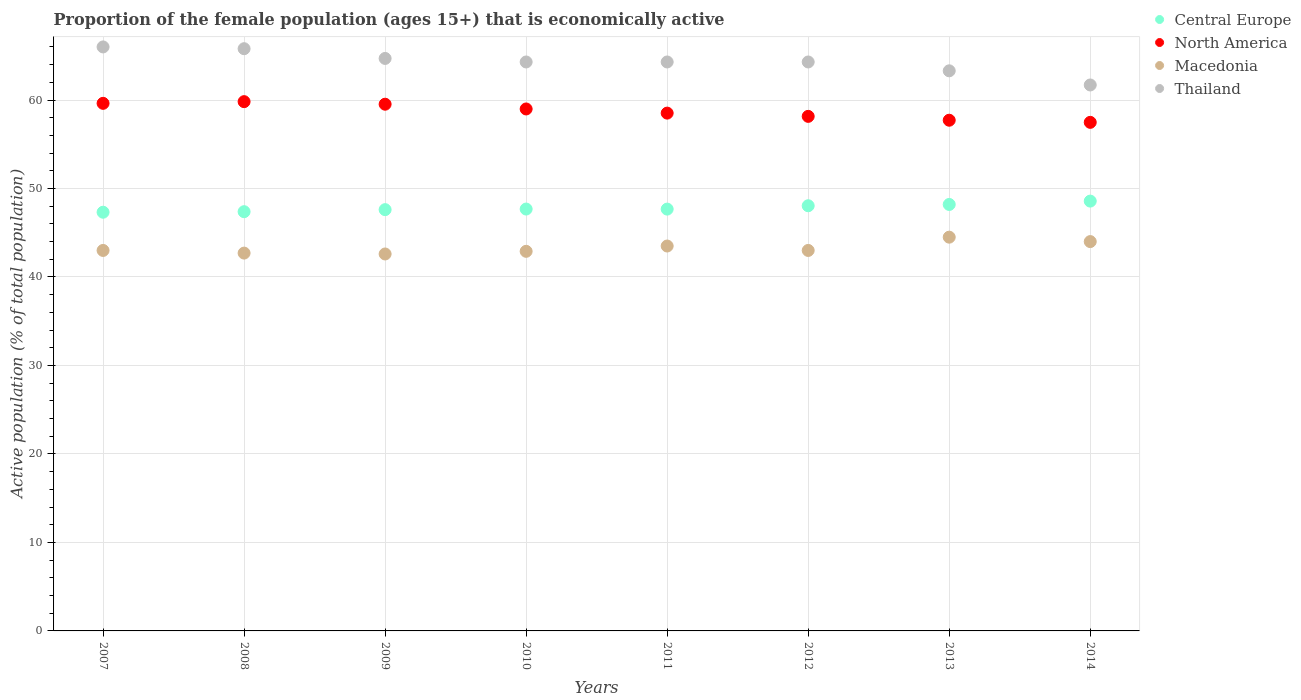What is the proportion of the female population that is economically active in Thailand in 2013?
Make the answer very short. 63.3. Across all years, what is the maximum proportion of the female population that is economically active in North America?
Your answer should be compact. 59.82. Across all years, what is the minimum proportion of the female population that is economically active in Macedonia?
Offer a very short reply. 42.6. In which year was the proportion of the female population that is economically active in Macedonia maximum?
Your answer should be compact. 2013. What is the total proportion of the female population that is economically active in Thailand in the graph?
Ensure brevity in your answer.  514.4. What is the difference between the proportion of the female population that is economically active in Central Europe in 2008 and that in 2014?
Provide a short and direct response. -1.2. What is the difference between the proportion of the female population that is economically active in Macedonia in 2013 and the proportion of the female population that is economically active in Central Europe in 2008?
Offer a very short reply. -2.88. What is the average proportion of the female population that is economically active in Macedonia per year?
Give a very brief answer. 43.28. In the year 2009, what is the difference between the proportion of the female population that is economically active in Central Europe and proportion of the female population that is economically active in Thailand?
Provide a short and direct response. -17.09. What is the ratio of the proportion of the female population that is economically active in Macedonia in 2008 to that in 2014?
Make the answer very short. 0.97. Is the difference between the proportion of the female population that is economically active in Central Europe in 2008 and 2011 greater than the difference between the proportion of the female population that is economically active in Thailand in 2008 and 2011?
Your answer should be very brief. No. What is the difference between the highest and the second highest proportion of the female population that is economically active in Thailand?
Your response must be concise. 0.2. What is the difference between the highest and the lowest proportion of the female population that is economically active in Central Europe?
Your response must be concise. 1.26. Is it the case that in every year, the sum of the proportion of the female population that is economically active in North America and proportion of the female population that is economically active in Central Europe  is greater than the proportion of the female population that is economically active in Thailand?
Ensure brevity in your answer.  Yes. Does the proportion of the female population that is economically active in Central Europe monotonically increase over the years?
Offer a very short reply. No. How many years are there in the graph?
Offer a terse response. 8. What is the difference between two consecutive major ticks on the Y-axis?
Keep it short and to the point. 10. Does the graph contain any zero values?
Make the answer very short. No. Does the graph contain grids?
Keep it short and to the point. Yes. Where does the legend appear in the graph?
Ensure brevity in your answer.  Top right. How many legend labels are there?
Your answer should be very brief. 4. What is the title of the graph?
Your answer should be very brief. Proportion of the female population (ages 15+) that is economically active. What is the label or title of the Y-axis?
Keep it short and to the point. Active population (% of total population). What is the Active population (% of total population) of Central Europe in 2007?
Keep it short and to the point. 47.32. What is the Active population (% of total population) of North America in 2007?
Your answer should be compact. 59.62. What is the Active population (% of total population) in Thailand in 2007?
Give a very brief answer. 66. What is the Active population (% of total population) in Central Europe in 2008?
Offer a terse response. 47.38. What is the Active population (% of total population) in North America in 2008?
Make the answer very short. 59.82. What is the Active population (% of total population) of Macedonia in 2008?
Your response must be concise. 42.7. What is the Active population (% of total population) of Thailand in 2008?
Offer a very short reply. 65.8. What is the Active population (% of total population) of Central Europe in 2009?
Offer a terse response. 47.61. What is the Active population (% of total population) in North America in 2009?
Offer a very short reply. 59.53. What is the Active population (% of total population) of Macedonia in 2009?
Provide a short and direct response. 42.6. What is the Active population (% of total population) of Thailand in 2009?
Provide a short and direct response. 64.7. What is the Active population (% of total population) in Central Europe in 2010?
Provide a succinct answer. 47.68. What is the Active population (% of total population) in North America in 2010?
Offer a very short reply. 58.99. What is the Active population (% of total population) in Macedonia in 2010?
Provide a short and direct response. 42.9. What is the Active population (% of total population) in Thailand in 2010?
Offer a very short reply. 64.3. What is the Active population (% of total population) in Central Europe in 2011?
Give a very brief answer. 47.67. What is the Active population (% of total population) in North America in 2011?
Provide a succinct answer. 58.52. What is the Active population (% of total population) of Macedonia in 2011?
Make the answer very short. 43.5. What is the Active population (% of total population) in Thailand in 2011?
Your answer should be compact. 64.3. What is the Active population (% of total population) of Central Europe in 2012?
Give a very brief answer. 48.05. What is the Active population (% of total population) in North America in 2012?
Give a very brief answer. 58.15. What is the Active population (% of total population) in Thailand in 2012?
Ensure brevity in your answer.  64.3. What is the Active population (% of total population) in Central Europe in 2013?
Make the answer very short. 48.2. What is the Active population (% of total population) in North America in 2013?
Your response must be concise. 57.72. What is the Active population (% of total population) in Macedonia in 2013?
Offer a terse response. 44.5. What is the Active population (% of total population) of Thailand in 2013?
Offer a terse response. 63.3. What is the Active population (% of total population) in Central Europe in 2014?
Provide a short and direct response. 48.58. What is the Active population (% of total population) of North America in 2014?
Your answer should be compact. 57.48. What is the Active population (% of total population) in Thailand in 2014?
Your answer should be very brief. 61.7. Across all years, what is the maximum Active population (% of total population) in Central Europe?
Offer a terse response. 48.58. Across all years, what is the maximum Active population (% of total population) of North America?
Keep it short and to the point. 59.82. Across all years, what is the maximum Active population (% of total population) of Macedonia?
Your answer should be very brief. 44.5. Across all years, what is the minimum Active population (% of total population) in Central Europe?
Your answer should be very brief. 47.32. Across all years, what is the minimum Active population (% of total population) in North America?
Ensure brevity in your answer.  57.48. Across all years, what is the minimum Active population (% of total population) in Macedonia?
Provide a succinct answer. 42.6. Across all years, what is the minimum Active population (% of total population) in Thailand?
Keep it short and to the point. 61.7. What is the total Active population (% of total population) of Central Europe in the graph?
Your response must be concise. 382.48. What is the total Active population (% of total population) of North America in the graph?
Offer a terse response. 469.82. What is the total Active population (% of total population) of Macedonia in the graph?
Ensure brevity in your answer.  346.2. What is the total Active population (% of total population) of Thailand in the graph?
Offer a terse response. 514.4. What is the difference between the Active population (% of total population) in Central Europe in 2007 and that in 2008?
Offer a very short reply. -0.06. What is the difference between the Active population (% of total population) of North America in 2007 and that in 2008?
Provide a succinct answer. -0.19. What is the difference between the Active population (% of total population) in Thailand in 2007 and that in 2008?
Your answer should be compact. 0.2. What is the difference between the Active population (% of total population) of Central Europe in 2007 and that in 2009?
Offer a terse response. -0.29. What is the difference between the Active population (% of total population) in North America in 2007 and that in 2009?
Your answer should be very brief. 0.1. What is the difference between the Active population (% of total population) in Central Europe in 2007 and that in 2010?
Make the answer very short. -0.36. What is the difference between the Active population (% of total population) in North America in 2007 and that in 2010?
Your answer should be compact. 0.64. What is the difference between the Active population (% of total population) in Thailand in 2007 and that in 2010?
Offer a very short reply. 1.7. What is the difference between the Active population (% of total population) of Central Europe in 2007 and that in 2011?
Give a very brief answer. -0.35. What is the difference between the Active population (% of total population) in North America in 2007 and that in 2011?
Provide a short and direct response. 1.1. What is the difference between the Active population (% of total population) of Thailand in 2007 and that in 2011?
Your answer should be very brief. 1.7. What is the difference between the Active population (% of total population) in Central Europe in 2007 and that in 2012?
Give a very brief answer. -0.73. What is the difference between the Active population (% of total population) of North America in 2007 and that in 2012?
Your answer should be very brief. 1.47. What is the difference between the Active population (% of total population) in Central Europe in 2007 and that in 2013?
Your response must be concise. -0.88. What is the difference between the Active population (% of total population) of North America in 2007 and that in 2013?
Ensure brevity in your answer.  1.91. What is the difference between the Active population (% of total population) of Central Europe in 2007 and that in 2014?
Make the answer very short. -1.26. What is the difference between the Active population (% of total population) of North America in 2007 and that in 2014?
Your answer should be compact. 2.15. What is the difference between the Active population (% of total population) in Macedonia in 2007 and that in 2014?
Provide a short and direct response. -1. What is the difference between the Active population (% of total population) of Central Europe in 2008 and that in 2009?
Give a very brief answer. -0.23. What is the difference between the Active population (% of total population) of North America in 2008 and that in 2009?
Ensure brevity in your answer.  0.29. What is the difference between the Active population (% of total population) of Central Europe in 2008 and that in 2010?
Give a very brief answer. -0.3. What is the difference between the Active population (% of total population) in North America in 2008 and that in 2010?
Your answer should be very brief. 0.83. What is the difference between the Active population (% of total population) of Macedonia in 2008 and that in 2010?
Give a very brief answer. -0.2. What is the difference between the Active population (% of total population) of Central Europe in 2008 and that in 2011?
Ensure brevity in your answer.  -0.29. What is the difference between the Active population (% of total population) in North America in 2008 and that in 2011?
Your answer should be very brief. 1.3. What is the difference between the Active population (% of total population) of Central Europe in 2008 and that in 2012?
Your response must be concise. -0.67. What is the difference between the Active population (% of total population) in North America in 2008 and that in 2012?
Give a very brief answer. 1.66. What is the difference between the Active population (% of total population) in Thailand in 2008 and that in 2012?
Keep it short and to the point. 1.5. What is the difference between the Active population (% of total population) in Central Europe in 2008 and that in 2013?
Make the answer very short. -0.82. What is the difference between the Active population (% of total population) in North America in 2008 and that in 2013?
Provide a short and direct response. 2.1. What is the difference between the Active population (% of total population) of Macedonia in 2008 and that in 2013?
Provide a succinct answer. -1.8. What is the difference between the Active population (% of total population) in Thailand in 2008 and that in 2013?
Make the answer very short. 2.5. What is the difference between the Active population (% of total population) of Central Europe in 2008 and that in 2014?
Give a very brief answer. -1.2. What is the difference between the Active population (% of total population) of North America in 2008 and that in 2014?
Make the answer very short. 2.34. What is the difference between the Active population (% of total population) of Macedonia in 2008 and that in 2014?
Give a very brief answer. -1.3. What is the difference between the Active population (% of total population) in Thailand in 2008 and that in 2014?
Offer a very short reply. 4.1. What is the difference between the Active population (% of total population) in Central Europe in 2009 and that in 2010?
Ensure brevity in your answer.  -0.07. What is the difference between the Active population (% of total population) of North America in 2009 and that in 2010?
Make the answer very short. 0.54. What is the difference between the Active population (% of total population) of Macedonia in 2009 and that in 2010?
Provide a short and direct response. -0.3. What is the difference between the Active population (% of total population) in Central Europe in 2009 and that in 2011?
Your answer should be very brief. -0.06. What is the difference between the Active population (% of total population) of North America in 2009 and that in 2011?
Provide a succinct answer. 1.01. What is the difference between the Active population (% of total population) in Macedonia in 2009 and that in 2011?
Give a very brief answer. -0.9. What is the difference between the Active population (% of total population) of Thailand in 2009 and that in 2011?
Your answer should be very brief. 0.4. What is the difference between the Active population (% of total population) of Central Europe in 2009 and that in 2012?
Offer a terse response. -0.44. What is the difference between the Active population (% of total population) of North America in 2009 and that in 2012?
Give a very brief answer. 1.37. What is the difference between the Active population (% of total population) in Thailand in 2009 and that in 2012?
Keep it short and to the point. 0.4. What is the difference between the Active population (% of total population) in Central Europe in 2009 and that in 2013?
Offer a very short reply. -0.59. What is the difference between the Active population (% of total population) of North America in 2009 and that in 2013?
Ensure brevity in your answer.  1.81. What is the difference between the Active population (% of total population) in Thailand in 2009 and that in 2013?
Provide a short and direct response. 1.4. What is the difference between the Active population (% of total population) in Central Europe in 2009 and that in 2014?
Make the answer very short. -0.97. What is the difference between the Active population (% of total population) of North America in 2009 and that in 2014?
Offer a terse response. 2.05. What is the difference between the Active population (% of total population) in Thailand in 2009 and that in 2014?
Your answer should be very brief. 3. What is the difference between the Active population (% of total population) in Central Europe in 2010 and that in 2011?
Offer a very short reply. 0.01. What is the difference between the Active population (% of total population) in North America in 2010 and that in 2011?
Your answer should be compact. 0.47. What is the difference between the Active population (% of total population) of Macedonia in 2010 and that in 2011?
Provide a short and direct response. -0.6. What is the difference between the Active population (% of total population) in Thailand in 2010 and that in 2011?
Give a very brief answer. 0. What is the difference between the Active population (% of total population) of Central Europe in 2010 and that in 2012?
Your answer should be compact. -0.37. What is the difference between the Active population (% of total population) of North America in 2010 and that in 2012?
Your answer should be very brief. 0.84. What is the difference between the Active population (% of total population) in Macedonia in 2010 and that in 2012?
Keep it short and to the point. -0.1. What is the difference between the Active population (% of total population) of Central Europe in 2010 and that in 2013?
Make the answer very short. -0.52. What is the difference between the Active population (% of total population) of North America in 2010 and that in 2013?
Your answer should be very brief. 1.27. What is the difference between the Active population (% of total population) in Macedonia in 2010 and that in 2013?
Provide a succinct answer. -1.6. What is the difference between the Active population (% of total population) in Thailand in 2010 and that in 2013?
Make the answer very short. 1. What is the difference between the Active population (% of total population) of Central Europe in 2010 and that in 2014?
Offer a very short reply. -0.9. What is the difference between the Active population (% of total population) in North America in 2010 and that in 2014?
Your answer should be very brief. 1.51. What is the difference between the Active population (% of total population) of Central Europe in 2011 and that in 2012?
Keep it short and to the point. -0.38. What is the difference between the Active population (% of total population) of North America in 2011 and that in 2012?
Your answer should be compact. 0.37. What is the difference between the Active population (% of total population) of Thailand in 2011 and that in 2012?
Your response must be concise. 0. What is the difference between the Active population (% of total population) of Central Europe in 2011 and that in 2013?
Offer a very short reply. -0.52. What is the difference between the Active population (% of total population) in North America in 2011 and that in 2013?
Your answer should be very brief. 0.8. What is the difference between the Active population (% of total population) in Macedonia in 2011 and that in 2013?
Offer a terse response. -1. What is the difference between the Active population (% of total population) in Central Europe in 2011 and that in 2014?
Your response must be concise. -0.9. What is the difference between the Active population (% of total population) in North America in 2011 and that in 2014?
Ensure brevity in your answer.  1.04. What is the difference between the Active population (% of total population) in Thailand in 2011 and that in 2014?
Your answer should be very brief. 2.6. What is the difference between the Active population (% of total population) in Central Europe in 2012 and that in 2013?
Your answer should be compact. -0.14. What is the difference between the Active population (% of total population) in North America in 2012 and that in 2013?
Your answer should be very brief. 0.44. What is the difference between the Active population (% of total population) of Central Europe in 2012 and that in 2014?
Keep it short and to the point. -0.53. What is the difference between the Active population (% of total population) in North America in 2012 and that in 2014?
Keep it short and to the point. 0.68. What is the difference between the Active population (% of total population) in Central Europe in 2013 and that in 2014?
Your answer should be very brief. -0.38. What is the difference between the Active population (% of total population) of North America in 2013 and that in 2014?
Give a very brief answer. 0.24. What is the difference between the Active population (% of total population) of Central Europe in 2007 and the Active population (% of total population) of North America in 2008?
Offer a very short reply. -12.5. What is the difference between the Active population (% of total population) of Central Europe in 2007 and the Active population (% of total population) of Macedonia in 2008?
Ensure brevity in your answer.  4.62. What is the difference between the Active population (% of total population) in Central Europe in 2007 and the Active population (% of total population) in Thailand in 2008?
Provide a short and direct response. -18.48. What is the difference between the Active population (% of total population) in North America in 2007 and the Active population (% of total population) in Macedonia in 2008?
Your answer should be very brief. 16.92. What is the difference between the Active population (% of total population) in North America in 2007 and the Active population (% of total population) in Thailand in 2008?
Your response must be concise. -6.18. What is the difference between the Active population (% of total population) of Macedonia in 2007 and the Active population (% of total population) of Thailand in 2008?
Give a very brief answer. -22.8. What is the difference between the Active population (% of total population) of Central Europe in 2007 and the Active population (% of total population) of North America in 2009?
Offer a terse response. -12.21. What is the difference between the Active population (% of total population) in Central Europe in 2007 and the Active population (% of total population) in Macedonia in 2009?
Your answer should be compact. 4.72. What is the difference between the Active population (% of total population) in Central Europe in 2007 and the Active population (% of total population) in Thailand in 2009?
Provide a short and direct response. -17.38. What is the difference between the Active population (% of total population) in North America in 2007 and the Active population (% of total population) in Macedonia in 2009?
Your answer should be compact. 17.02. What is the difference between the Active population (% of total population) in North America in 2007 and the Active population (% of total population) in Thailand in 2009?
Keep it short and to the point. -5.08. What is the difference between the Active population (% of total population) in Macedonia in 2007 and the Active population (% of total population) in Thailand in 2009?
Your response must be concise. -21.7. What is the difference between the Active population (% of total population) in Central Europe in 2007 and the Active population (% of total population) in North America in 2010?
Offer a terse response. -11.67. What is the difference between the Active population (% of total population) in Central Europe in 2007 and the Active population (% of total population) in Macedonia in 2010?
Provide a short and direct response. 4.42. What is the difference between the Active population (% of total population) of Central Europe in 2007 and the Active population (% of total population) of Thailand in 2010?
Provide a succinct answer. -16.98. What is the difference between the Active population (% of total population) of North America in 2007 and the Active population (% of total population) of Macedonia in 2010?
Keep it short and to the point. 16.72. What is the difference between the Active population (% of total population) of North America in 2007 and the Active population (% of total population) of Thailand in 2010?
Provide a short and direct response. -4.68. What is the difference between the Active population (% of total population) in Macedonia in 2007 and the Active population (% of total population) in Thailand in 2010?
Ensure brevity in your answer.  -21.3. What is the difference between the Active population (% of total population) of Central Europe in 2007 and the Active population (% of total population) of North America in 2011?
Keep it short and to the point. -11.2. What is the difference between the Active population (% of total population) in Central Europe in 2007 and the Active population (% of total population) in Macedonia in 2011?
Make the answer very short. 3.82. What is the difference between the Active population (% of total population) of Central Europe in 2007 and the Active population (% of total population) of Thailand in 2011?
Offer a terse response. -16.98. What is the difference between the Active population (% of total population) of North America in 2007 and the Active population (% of total population) of Macedonia in 2011?
Ensure brevity in your answer.  16.12. What is the difference between the Active population (% of total population) of North America in 2007 and the Active population (% of total population) of Thailand in 2011?
Your answer should be compact. -4.68. What is the difference between the Active population (% of total population) of Macedonia in 2007 and the Active population (% of total population) of Thailand in 2011?
Your answer should be compact. -21.3. What is the difference between the Active population (% of total population) in Central Europe in 2007 and the Active population (% of total population) in North America in 2012?
Give a very brief answer. -10.83. What is the difference between the Active population (% of total population) in Central Europe in 2007 and the Active population (% of total population) in Macedonia in 2012?
Offer a very short reply. 4.32. What is the difference between the Active population (% of total population) of Central Europe in 2007 and the Active population (% of total population) of Thailand in 2012?
Provide a short and direct response. -16.98. What is the difference between the Active population (% of total population) of North America in 2007 and the Active population (% of total population) of Macedonia in 2012?
Provide a succinct answer. 16.62. What is the difference between the Active population (% of total population) of North America in 2007 and the Active population (% of total population) of Thailand in 2012?
Offer a very short reply. -4.68. What is the difference between the Active population (% of total population) of Macedonia in 2007 and the Active population (% of total population) of Thailand in 2012?
Your response must be concise. -21.3. What is the difference between the Active population (% of total population) of Central Europe in 2007 and the Active population (% of total population) of North America in 2013?
Make the answer very short. -10.4. What is the difference between the Active population (% of total population) in Central Europe in 2007 and the Active population (% of total population) in Macedonia in 2013?
Your response must be concise. 2.82. What is the difference between the Active population (% of total population) in Central Europe in 2007 and the Active population (% of total population) in Thailand in 2013?
Your answer should be very brief. -15.98. What is the difference between the Active population (% of total population) in North America in 2007 and the Active population (% of total population) in Macedonia in 2013?
Your answer should be compact. 15.12. What is the difference between the Active population (% of total population) in North America in 2007 and the Active population (% of total population) in Thailand in 2013?
Ensure brevity in your answer.  -3.68. What is the difference between the Active population (% of total population) of Macedonia in 2007 and the Active population (% of total population) of Thailand in 2013?
Offer a very short reply. -20.3. What is the difference between the Active population (% of total population) of Central Europe in 2007 and the Active population (% of total population) of North America in 2014?
Provide a succinct answer. -10.16. What is the difference between the Active population (% of total population) in Central Europe in 2007 and the Active population (% of total population) in Macedonia in 2014?
Give a very brief answer. 3.32. What is the difference between the Active population (% of total population) in Central Europe in 2007 and the Active population (% of total population) in Thailand in 2014?
Offer a very short reply. -14.38. What is the difference between the Active population (% of total population) in North America in 2007 and the Active population (% of total population) in Macedonia in 2014?
Give a very brief answer. 15.62. What is the difference between the Active population (% of total population) in North America in 2007 and the Active population (% of total population) in Thailand in 2014?
Your answer should be compact. -2.08. What is the difference between the Active population (% of total population) in Macedonia in 2007 and the Active population (% of total population) in Thailand in 2014?
Offer a very short reply. -18.7. What is the difference between the Active population (% of total population) of Central Europe in 2008 and the Active population (% of total population) of North America in 2009?
Offer a terse response. -12.15. What is the difference between the Active population (% of total population) in Central Europe in 2008 and the Active population (% of total population) in Macedonia in 2009?
Give a very brief answer. 4.78. What is the difference between the Active population (% of total population) of Central Europe in 2008 and the Active population (% of total population) of Thailand in 2009?
Give a very brief answer. -17.32. What is the difference between the Active population (% of total population) of North America in 2008 and the Active population (% of total population) of Macedonia in 2009?
Provide a succinct answer. 17.22. What is the difference between the Active population (% of total population) of North America in 2008 and the Active population (% of total population) of Thailand in 2009?
Your answer should be very brief. -4.88. What is the difference between the Active population (% of total population) of Central Europe in 2008 and the Active population (% of total population) of North America in 2010?
Ensure brevity in your answer.  -11.61. What is the difference between the Active population (% of total population) in Central Europe in 2008 and the Active population (% of total population) in Macedonia in 2010?
Make the answer very short. 4.48. What is the difference between the Active population (% of total population) of Central Europe in 2008 and the Active population (% of total population) of Thailand in 2010?
Provide a succinct answer. -16.92. What is the difference between the Active population (% of total population) of North America in 2008 and the Active population (% of total population) of Macedonia in 2010?
Make the answer very short. 16.92. What is the difference between the Active population (% of total population) in North America in 2008 and the Active population (% of total population) in Thailand in 2010?
Offer a terse response. -4.48. What is the difference between the Active population (% of total population) of Macedonia in 2008 and the Active population (% of total population) of Thailand in 2010?
Offer a very short reply. -21.6. What is the difference between the Active population (% of total population) of Central Europe in 2008 and the Active population (% of total population) of North America in 2011?
Offer a terse response. -11.14. What is the difference between the Active population (% of total population) of Central Europe in 2008 and the Active population (% of total population) of Macedonia in 2011?
Keep it short and to the point. 3.88. What is the difference between the Active population (% of total population) of Central Europe in 2008 and the Active population (% of total population) of Thailand in 2011?
Give a very brief answer. -16.92. What is the difference between the Active population (% of total population) in North America in 2008 and the Active population (% of total population) in Macedonia in 2011?
Keep it short and to the point. 16.32. What is the difference between the Active population (% of total population) in North America in 2008 and the Active population (% of total population) in Thailand in 2011?
Your answer should be compact. -4.48. What is the difference between the Active population (% of total population) in Macedonia in 2008 and the Active population (% of total population) in Thailand in 2011?
Your answer should be compact. -21.6. What is the difference between the Active population (% of total population) in Central Europe in 2008 and the Active population (% of total population) in North America in 2012?
Your answer should be compact. -10.77. What is the difference between the Active population (% of total population) of Central Europe in 2008 and the Active population (% of total population) of Macedonia in 2012?
Make the answer very short. 4.38. What is the difference between the Active population (% of total population) in Central Europe in 2008 and the Active population (% of total population) in Thailand in 2012?
Your response must be concise. -16.92. What is the difference between the Active population (% of total population) of North America in 2008 and the Active population (% of total population) of Macedonia in 2012?
Keep it short and to the point. 16.82. What is the difference between the Active population (% of total population) in North America in 2008 and the Active population (% of total population) in Thailand in 2012?
Make the answer very short. -4.48. What is the difference between the Active population (% of total population) in Macedonia in 2008 and the Active population (% of total population) in Thailand in 2012?
Keep it short and to the point. -21.6. What is the difference between the Active population (% of total population) in Central Europe in 2008 and the Active population (% of total population) in North America in 2013?
Keep it short and to the point. -10.34. What is the difference between the Active population (% of total population) in Central Europe in 2008 and the Active population (% of total population) in Macedonia in 2013?
Keep it short and to the point. 2.88. What is the difference between the Active population (% of total population) of Central Europe in 2008 and the Active population (% of total population) of Thailand in 2013?
Offer a terse response. -15.92. What is the difference between the Active population (% of total population) of North America in 2008 and the Active population (% of total population) of Macedonia in 2013?
Your response must be concise. 15.32. What is the difference between the Active population (% of total population) in North America in 2008 and the Active population (% of total population) in Thailand in 2013?
Offer a very short reply. -3.48. What is the difference between the Active population (% of total population) of Macedonia in 2008 and the Active population (% of total population) of Thailand in 2013?
Ensure brevity in your answer.  -20.6. What is the difference between the Active population (% of total population) in Central Europe in 2008 and the Active population (% of total population) in North America in 2014?
Give a very brief answer. -10.1. What is the difference between the Active population (% of total population) in Central Europe in 2008 and the Active population (% of total population) in Macedonia in 2014?
Make the answer very short. 3.38. What is the difference between the Active population (% of total population) of Central Europe in 2008 and the Active population (% of total population) of Thailand in 2014?
Provide a succinct answer. -14.32. What is the difference between the Active population (% of total population) in North America in 2008 and the Active population (% of total population) in Macedonia in 2014?
Offer a terse response. 15.82. What is the difference between the Active population (% of total population) of North America in 2008 and the Active population (% of total population) of Thailand in 2014?
Offer a very short reply. -1.88. What is the difference between the Active population (% of total population) in Central Europe in 2009 and the Active population (% of total population) in North America in 2010?
Your answer should be very brief. -11.38. What is the difference between the Active population (% of total population) in Central Europe in 2009 and the Active population (% of total population) in Macedonia in 2010?
Give a very brief answer. 4.71. What is the difference between the Active population (% of total population) in Central Europe in 2009 and the Active population (% of total population) in Thailand in 2010?
Give a very brief answer. -16.69. What is the difference between the Active population (% of total population) in North America in 2009 and the Active population (% of total population) in Macedonia in 2010?
Your response must be concise. 16.63. What is the difference between the Active population (% of total population) of North America in 2009 and the Active population (% of total population) of Thailand in 2010?
Your answer should be compact. -4.77. What is the difference between the Active population (% of total population) of Macedonia in 2009 and the Active population (% of total population) of Thailand in 2010?
Your answer should be very brief. -21.7. What is the difference between the Active population (% of total population) of Central Europe in 2009 and the Active population (% of total population) of North America in 2011?
Provide a short and direct response. -10.91. What is the difference between the Active population (% of total population) in Central Europe in 2009 and the Active population (% of total population) in Macedonia in 2011?
Offer a terse response. 4.11. What is the difference between the Active population (% of total population) in Central Europe in 2009 and the Active population (% of total population) in Thailand in 2011?
Ensure brevity in your answer.  -16.69. What is the difference between the Active population (% of total population) of North America in 2009 and the Active population (% of total population) of Macedonia in 2011?
Ensure brevity in your answer.  16.03. What is the difference between the Active population (% of total population) in North America in 2009 and the Active population (% of total population) in Thailand in 2011?
Give a very brief answer. -4.77. What is the difference between the Active population (% of total population) in Macedonia in 2009 and the Active population (% of total population) in Thailand in 2011?
Your response must be concise. -21.7. What is the difference between the Active population (% of total population) in Central Europe in 2009 and the Active population (% of total population) in North America in 2012?
Your response must be concise. -10.54. What is the difference between the Active population (% of total population) in Central Europe in 2009 and the Active population (% of total population) in Macedonia in 2012?
Give a very brief answer. 4.61. What is the difference between the Active population (% of total population) in Central Europe in 2009 and the Active population (% of total population) in Thailand in 2012?
Keep it short and to the point. -16.69. What is the difference between the Active population (% of total population) in North America in 2009 and the Active population (% of total population) in Macedonia in 2012?
Make the answer very short. 16.53. What is the difference between the Active population (% of total population) in North America in 2009 and the Active population (% of total population) in Thailand in 2012?
Give a very brief answer. -4.77. What is the difference between the Active population (% of total population) of Macedonia in 2009 and the Active population (% of total population) of Thailand in 2012?
Your answer should be compact. -21.7. What is the difference between the Active population (% of total population) of Central Europe in 2009 and the Active population (% of total population) of North America in 2013?
Offer a terse response. -10.11. What is the difference between the Active population (% of total population) of Central Europe in 2009 and the Active population (% of total population) of Macedonia in 2013?
Your answer should be compact. 3.11. What is the difference between the Active population (% of total population) in Central Europe in 2009 and the Active population (% of total population) in Thailand in 2013?
Give a very brief answer. -15.69. What is the difference between the Active population (% of total population) of North America in 2009 and the Active population (% of total population) of Macedonia in 2013?
Provide a short and direct response. 15.03. What is the difference between the Active population (% of total population) of North America in 2009 and the Active population (% of total population) of Thailand in 2013?
Give a very brief answer. -3.77. What is the difference between the Active population (% of total population) in Macedonia in 2009 and the Active population (% of total population) in Thailand in 2013?
Offer a very short reply. -20.7. What is the difference between the Active population (% of total population) in Central Europe in 2009 and the Active population (% of total population) in North America in 2014?
Your answer should be compact. -9.87. What is the difference between the Active population (% of total population) in Central Europe in 2009 and the Active population (% of total population) in Macedonia in 2014?
Make the answer very short. 3.61. What is the difference between the Active population (% of total population) of Central Europe in 2009 and the Active population (% of total population) of Thailand in 2014?
Provide a short and direct response. -14.09. What is the difference between the Active population (% of total population) in North America in 2009 and the Active population (% of total population) in Macedonia in 2014?
Provide a short and direct response. 15.53. What is the difference between the Active population (% of total population) in North America in 2009 and the Active population (% of total population) in Thailand in 2014?
Your answer should be very brief. -2.17. What is the difference between the Active population (% of total population) of Macedonia in 2009 and the Active population (% of total population) of Thailand in 2014?
Provide a succinct answer. -19.1. What is the difference between the Active population (% of total population) in Central Europe in 2010 and the Active population (% of total population) in North America in 2011?
Your answer should be very brief. -10.84. What is the difference between the Active population (% of total population) in Central Europe in 2010 and the Active population (% of total population) in Macedonia in 2011?
Offer a very short reply. 4.18. What is the difference between the Active population (% of total population) of Central Europe in 2010 and the Active population (% of total population) of Thailand in 2011?
Ensure brevity in your answer.  -16.62. What is the difference between the Active population (% of total population) of North America in 2010 and the Active population (% of total population) of Macedonia in 2011?
Give a very brief answer. 15.49. What is the difference between the Active population (% of total population) of North America in 2010 and the Active population (% of total population) of Thailand in 2011?
Offer a very short reply. -5.31. What is the difference between the Active population (% of total population) of Macedonia in 2010 and the Active population (% of total population) of Thailand in 2011?
Give a very brief answer. -21.4. What is the difference between the Active population (% of total population) of Central Europe in 2010 and the Active population (% of total population) of North America in 2012?
Offer a terse response. -10.47. What is the difference between the Active population (% of total population) in Central Europe in 2010 and the Active population (% of total population) in Macedonia in 2012?
Your answer should be very brief. 4.68. What is the difference between the Active population (% of total population) in Central Europe in 2010 and the Active population (% of total population) in Thailand in 2012?
Offer a terse response. -16.62. What is the difference between the Active population (% of total population) in North America in 2010 and the Active population (% of total population) in Macedonia in 2012?
Offer a terse response. 15.99. What is the difference between the Active population (% of total population) in North America in 2010 and the Active population (% of total population) in Thailand in 2012?
Provide a succinct answer. -5.31. What is the difference between the Active population (% of total population) of Macedonia in 2010 and the Active population (% of total population) of Thailand in 2012?
Your response must be concise. -21.4. What is the difference between the Active population (% of total population) in Central Europe in 2010 and the Active population (% of total population) in North America in 2013?
Your answer should be compact. -10.04. What is the difference between the Active population (% of total population) of Central Europe in 2010 and the Active population (% of total population) of Macedonia in 2013?
Your response must be concise. 3.18. What is the difference between the Active population (% of total population) in Central Europe in 2010 and the Active population (% of total population) in Thailand in 2013?
Ensure brevity in your answer.  -15.62. What is the difference between the Active population (% of total population) of North America in 2010 and the Active population (% of total population) of Macedonia in 2013?
Make the answer very short. 14.49. What is the difference between the Active population (% of total population) in North America in 2010 and the Active population (% of total population) in Thailand in 2013?
Ensure brevity in your answer.  -4.31. What is the difference between the Active population (% of total population) of Macedonia in 2010 and the Active population (% of total population) of Thailand in 2013?
Your answer should be compact. -20.4. What is the difference between the Active population (% of total population) of Central Europe in 2010 and the Active population (% of total population) of North America in 2014?
Ensure brevity in your answer.  -9.8. What is the difference between the Active population (% of total population) of Central Europe in 2010 and the Active population (% of total population) of Macedonia in 2014?
Offer a terse response. 3.68. What is the difference between the Active population (% of total population) of Central Europe in 2010 and the Active population (% of total population) of Thailand in 2014?
Make the answer very short. -14.02. What is the difference between the Active population (% of total population) of North America in 2010 and the Active population (% of total population) of Macedonia in 2014?
Keep it short and to the point. 14.99. What is the difference between the Active population (% of total population) in North America in 2010 and the Active population (% of total population) in Thailand in 2014?
Provide a short and direct response. -2.71. What is the difference between the Active population (% of total population) in Macedonia in 2010 and the Active population (% of total population) in Thailand in 2014?
Offer a very short reply. -18.8. What is the difference between the Active population (% of total population) in Central Europe in 2011 and the Active population (% of total population) in North America in 2012?
Keep it short and to the point. -10.48. What is the difference between the Active population (% of total population) of Central Europe in 2011 and the Active population (% of total population) of Macedonia in 2012?
Provide a short and direct response. 4.67. What is the difference between the Active population (% of total population) of Central Europe in 2011 and the Active population (% of total population) of Thailand in 2012?
Ensure brevity in your answer.  -16.63. What is the difference between the Active population (% of total population) in North America in 2011 and the Active population (% of total population) in Macedonia in 2012?
Your response must be concise. 15.52. What is the difference between the Active population (% of total population) of North America in 2011 and the Active population (% of total population) of Thailand in 2012?
Give a very brief answer. -5.78. What is the difference between the Active population (% of total population) of Macedonia in 2011 and the Active population (% of total population) of Thailand in 2012?
Offer a terse response. -20.8. What is the difference between the Active population (% of total population) in Central Europe in 2011 and the Active population (% of total population) in North America in 2013?
Provide a succinct answer. -10.04. What is the difference between the Active population (% of total population) in Central Europe in 2011 and the Active population (% of total population) in Macedonia in 2013?
Offer a very short reply. 3.17. What is the difference between the Active population (% of total population) in Central Europe in 2011 and the Active population (% of total population) in Thailand in 2013?
Provide a short and direct response. -15.63. What is the difference between the Active population (% of total population) of North America in 2011 and the Active population (% of total population) of Macedonia in 2013?
Your answer should be very brief. 14.02. What is the difference between the Active population (% of total population) of North America in 2011 and the Active population (% of total population) of Thailand in 2013?
Provide a succinct answer. -4.78. What is the difference between the Active population (% of total population) of Macedonia in 2011 and the Active population (% of total population) of Thailand in 2013?
Offer a terse response. -19.8. What is the difference between the Active population (% of total population) in Central Europe in 2011 and the Active population (% of total population) in North America in 2014?
Give a very brief answer. -9.8. What is the difference between the Active population (% of total population) in Central Europe in 2011 and the Active population (% of total population) in Macedonia in 2014?
Ensure brevity in your answer.  3.67. What is the difference between the Active population (% of total population) of Central Europe in 2011 and the Active population (% of total population) of Thailand in 2014?
Your answer should be compact. -14.03. What is the difference between the Active population (% of total population) of North America in 2011 and the Active population (% of total population) of Macedonia in 2014?
Offer a very short reply. 14.52. What is the difference between the Active population (% of total population) in North America in 2011 and the Active population (% of total population) in Thailand in 2014?
Ensure brevity in your answer.  -3.18. What is the difference between the Active population (% of total population) in Macedonia in 2011 and the Active population (% of total population) in Thailand in 2014?
Your answer should be compact. -18.2. What is the difference between the Active population (% of total population) in Central Europe in 2012 and the Active population (% of total population) in North America in 2013?
Your response must be concise. -9.66. What is the difference between the Active population (% of total population) of Central Europe in 2012 and the Active population (% of total population) of Macedonia in 2013?
Provide a succinct answer. 3.55. What is the difference between the Active population (% of total population) in Central Europe in 2012 and the Active population (% of total population) in Thailand in 2013?
Your answer should be very brief. -15.25. What is the difference between the Active population (% of total population) of North America in 2012 and the Active population (% of total population) of Macedonia in 2013?
Offer a terse response. 13.65. What is the difference between the Active population (% of total population) in North America in 2012 and the Active population (% of total population) in Thailand in 2013?
Offer a very short reply. -5.15. What is the difference between the Active population (% of total population) in Macedonia in 2012 and the Active population (% of total population) in Thailand in 2013?
Your answer should be very brief. -20.3. What is the difference between the Active population (% of total population) in Central Europe in 2012 and the Active population (% of total population) in North America in 2014?
Provide a short and direct response. -9.43. What is the difference between the Active population (% of total population) in Central Europe in 2012 and the Active population (% of total population) in Macedonia in 2014?
Your response must be concise. 4.05. What is the difference between the Active population (% of total population) of Central Europe in 2012 and the Active population (% of total population) of Thailand in 2014?
Make the answer very short. -13.65. What is the difference between the Active population (% of total population) in North America in 2012 and the Active population (% of total population) in Macedonia in 2014?
Ensure brevity in your answer.  14.15. What is the difference between the Active population (% of total population) in North America in 2012 and the Active population (% of total population) in Thailand in 2014?
Offer a very short reply. -3.55. What is the difference between the Active population (% of total population) in Macedonia in 2012 and the Active population (% of total population) in Thailand in 2014?
Provide a succinct answer. -18.7. What is the difference between the Active population (% of total population) in Central Europe in 2013 and the Active population (% of total population) in North America in 2014?
Provide a short and direct response. -9.28. What is the difference between the Active population (% of total population) in Central Europe in 2013 and the Active population (% of total population) in Macedonia in 2014?
Give a very brief answer. 4.2. What is the difference between the Active population (% of total population) in Central Europe in 2013 and the Active population (% of total population) in Thailand in 2014?
Your answer should be very brief. -13.5. What is the difference between the Active population (% of total population) of North America in 2013 and the Active population (% of total population) of Macedonia in 2014?
Offer a terse response. 13.72. What is the difference between the Active population (% of total population) in North America in 2013 and the Active population (% of total population) in Thailand in 2014?
Offer a terse response. -3.98. What is the difference between the Active population (% of total population) of Macedonia in 2013 and the Active population (% of total population) of Thailand in 2014?
Provide a succinct answer. -17.2. What is the average Active population (% of total population) of Central Europe per year?
Offer a terse response. 47.81. What is the average Active population (% of total population) of North America per year?
Ensure brevity in your answer.  58.73. What is the average Active population (% of total population) in Macedonia per year?
Offer a very short reply. 43.27. What is the average Active population (% of total population) in Thailand per year?
Provide a short and direct response. 64.3. In the year 2007, what is the difference between the Active population (% of total population) in Central Europe and Active population (% of total population) in North America?
Keep it short and to the point. -12.31. In the year 2007, what is the difference between the Active population (% of total population) of Central Europe and Active population (% of total population) of Macedonia?
Your answer should be very brief. 4.32. In the year 2007, what is the difference between the Active population (% of total population) in Central Europe and Active population (% of total population) in Thailand?
Make the answer very short. -18.68. In the year 2007, what is the difference between the Active population (% of total population) in North America and Active population (% of total population) in Macedonia?
Offer a terse response. 16.62. In the year 2007, what is the difference between the Active population (% of total population) of North America and Active population (% of total population) of Thailand?
Your response must be concise. -6.38. In the year 2008, what is the difference between the Active population (% of total population) of Central Europe and Active population (% of total population) of North America?
Your response must be concise. -12.44. In the year 2008, what is the difference between the Active population (% of total population) in Central Europe and Active population (% of total population) in Macedonia?
Your response must be concise. 4.68. In the year 2008, what is the difference between the Active population (% of total population) of Central Europe and Active population (% of total population) of Thailand?
Keep it short and to the point. -18.42. In the year 2008, what is the difference between the Active population (% of total population) in North America and Active population (% of total population) in Macedonia?
Your answer should be very brief. 17.12. In the year 2008, what is the difference between the Active population (% of total population) of North America and Active population (% of total population) of Thailand?
Offer a terse response. -5.98. In the year 2008, what is the difference between the Active population (% of total population) of Macedonia and Active population (% of total population) of Thailand?
Keep it short and to the point. -23.1. In the year 2009, what is the difference between the Active population (% of total population) in Central Europe and Active population (% of total population) in North America?
Provide a succinct answer. -11.92. In the year 2009, what is the difference between the Active population (% of total population) of Central Europe and Active population (% of total population) of Macedonia?
Keep it short and to the point. 5.01. In the year 2009, what is the difference between the Active population (% of total population) in Central Europe and Active population (% of total population) in Thailand?
Provide a short and direct response. -17.09. In the year 2009, what is the difference between the Active population (% of total population) in North America and Active population (% of total population) in Macedonia?
Your answer should be compact. 16.93. In the year 2009, what is the difference between the Active population (% of total population) in North America and Active population (% of total population) in Thailand?
Keep it short and to the point. -5.17. In the year 2009, what is the difference between the Active population (% of total population) of Macedonia and Active population (% of total population) of Thailand?
Ensure brevity in your answer.  -22.1. In the year 2010, what is the difference between the Active population (% of total population) of Central Europe and Active population (% of total population) of North America?
Offer a very short reply. -11.31. In the year 2010, what is the difference between the Active population (% of total population) in Central Europe and Active population (% of total population) in Macedonia?
Your answer should be compact. 4.78. In the year 2010, what is the difference between the Active population (% of total population) in Central Europe and Active population (% of total population) in Thailand?
Make the answer very short. -16.62. In the year 2010, what is the difference between the Active population (% of total population) in North America and Active population (% of total population) in Macedonia?
Keep it short and to the point. 16.09. In the year 2010, what is the difference between the Active population (% of total population) in North America and Active population (% of total population) in Thailand?
Your answer should be very brief. -5.31. In the year 2010, what is the difference between the Active population (% of total population) in Macedonia and Active population (% of total population) in Thailand?
Offer a very short reply. -21.4. In the year 2011, what is the difference between the Active population (% of total population) of Central Europe and Active population (% of total population) of North America?
Your answer should be very brief. -10.85. In the year 2011, what is the difference between the Active population (% of total population) in Central Europe and Active population (% of total population) in Macedonia?
Give a very brief answer. 4.17. In the year 2011, what is the difference between the Active population (% of total population) of Central Europe and Active population (% of total population) of Thailand?
Give a very brief answer. -16.63. In the year 2011, what is the difference between the Active population (% of total population) of North America and Active population (% of total population) of Macedonia?
Offer a very short reply. 15.02. In the year 2011, what is the difference between the Active population (% of total population) of North America and Active population (% of total population) of Thailand?
Give a very brief answer. -5.78. In the year 2011, what is the difference between the Active population (% of total population) of Macedonia and Active population (% of total population) of Thailand?
Provide a succinct answer. -20.8. In the year 2012, what is the difference between the Active population (% of total population) of Central Europe and Active population (% of total population) of North America?
Offer a terse response. -10.1. In the year 2012, what is the difference between the Active population (% of total population) in Central Europe and Active population (% of total population) in Macedonia?
Give a very brief answer. 5.05. In the year 2012, what is the difference between the Active population (% of total population) in Central Europe and Active population (% of total population) in Thailand?
Ensure brevity in your answer.  -16.25. In the year 2012, what is the difference between the Active population (% of total population) of North America and Active population (% of total population) of Macedonia?
Your answer should be very brief. 15.15. In the year 2012, what is the difference between the Active population (% of total population) of North America and Active population (% of total population) of Thailand?
Make the answer very short. -6.15. In the year 2012, what is the difference between the Active population (% of total population) of Macedonia and Active population (% of total population) of Thailand?
Provide a succinct answer. -21.3. In the year 2013, what is the difference between the Active population (% of total population) in Central Europe and Active population (% of total population) in North America?
Keep it short and to the point. -9.52. In the year 2013, what is the difference between the Active population (% of total population) of Central Europe and Active population (% of total population) of Macedonia?
Provide a short and direct response. 3.7. In the year 2013, what is the difference between the Active population (% of total population) of Central Europe and Active population (% of total population) of Thailand?
Your response must be concise. -15.1. In the year 2013, what is the difference between the Active population (% of total population) in North America and Active population (% of total population) in Macedonia?
Ensure brevity in your answer.  13.22. In the year 2013, what is the difference between the Active population (% of total population) of North America and Active population (% of total population) of Thailand?
Give a very brief answer. -5.58. In the year 2013, what is the difference between the Active population (% of total population) of Macedonia and Active population (% of total population) of Thailand?
Your response must be concise. -18.8. In the year 2014, what is the difference between the Active population (% of total population) in Central Europe and Active population (% of total population) in North America?
Your answer should be very brief. -8.9. In the year 2014, what is the difference between the Active population (% of total population) of Central Europe and Active population (% of total population) of Macedonia?
Give a very brief answer. 4.58. In the year 2014, what is the difference between the Active population (% of total population) in Central Europe and Active population (% of total population) in Thailand?
Provide a short and direct response. -13.12. In the year 2014, what is the difference between the Active population (% of total population) of North America and Active population (% of total population) of Macedonia?
Offer a terse response. 13.48. In the year 2014, what is the difference between the Active population (% of total population) of North America and Active population (% of total population) of Thailand?
Offer a terse response. -4.22. In the year 2014, what is the difference between the Active population (% of total population) in Macedonia and Active population (% of total population) in Thailand?
Your answer should be very brief. -17.7. What is the ratio of the Active population (% of total population) in Central Europe in 2007 to that in 2008?
Your response must be concise. 1. What is the ratio of the Active population (% of total population) of North America in 2007 to that in 2008?
Make the answer very short. 1. What is the ratio of the Active population (% of total population) of Macedonia in 2007 to that in 2008?
Your response must be concise. 1.01. What is the ratio of the Active population (% of total population) of Thailand in 2007 to that in 2008?
Give a very brief answer. 1. What is the ratio of the Active population (% of total population) in Central Europe in 2007 to that in 2009?
Give a very brief answer. 0.99. What is the ratio of the Active population (% of total population) of Macedonia in 2007 to that in 2009?
Provide a short and direct response. 1.01. What is the ratio of the Active population (% of total population) of Thailand in 2007 to that in 2009?
Your answer should be very brief. 1.02. What is the ratio of the Active population (% of total population) of Central Europe in 2007 to that in 2010?
Give a very brief answer. 0.99. What is the ratio of the Active population (% of total population) in North America in 2007 to that in 2010?
Your response must be concise. 1.01. What is the ratio of the Active population (% of total population) of Thailand in 2007 to that in 2010?
Offer a terse response. 1.03. What is the ratio of the Active population (% of total population) in North America in 2007 to that in 2011?
Offer a very short reply. 1.02. What is the ratio of the Active population (% of total population) in Macedonia in 2007 to that in 2011?
Your answer should be very brief. 0.99. What is the ratio of the Active population (% of total population) in Thailand in 2007 to that in 2011?
Keep it short and to the point. 1.03. What is the ratio of the Active population (% of total population) of Central Europe in 2007 to that in 2012?
Ensure brevity in your answer.  0.98. What is the ratio of the Active population (% of total population) of North America in 2007 to that in 2012?
Offer a terse response. 1.03. What is the ratio of the Active population (% of total population) in Macedonia in 2007 to that in 2012?
Your response must be concise. 1. What is the ratio of the Active population (% of total population) in Thailand in 2007 to that in 2012?
Your response must be concise. 1.03. What is the ratio of the Active population (% of total population) of Central Europe in 2007 to that in 2013?
Provide a succinct answer. 0.98. What is the ratio of the Active population (% of total population) in North America in 2007 to that in 2013?
Ensure brevity in your answer.  1.03. What is the ratio of the Active population (% of total population) of Macedonia in 2007 to that in 2013?
Provide a succinct answer. 0.97. What is the ratio of the Active population (% of total population) in Thailand in 2007 to that in 2013?
Give a very brief answer. 1.04. What is the ratio of the Active population (% of total population) of Central Europe in 2007 to that in 2014?
Give a very brief answer. 0.97. What is the ratio of the Active population (% of total population) in North America in 2007 to that in 2014?
Keep it short and to the point. 1.04. What is the ratio of the Active population (% of total population) in Macedonia in 2007 to that in 2014?
Make the answer very short. 0.98. What is the ratio of the Active population (% of total population) of Thailand in 2007 to that in 2014?
Offer a very short reply. 1.07. What is the ratio of the Active population (% of total population) of Central Europe in 2008 to that in 2009?
Your answer should be very brief. 1. What is the ratio of the Active population (% of total population) in North America in 2008 to that in 2009?
Provide a short and direct response. 1. What is the ratio of the Active population (% of total population) of Macedonia in 2008 to that in 2009?
Your response must be concise. 1. What is the ratio of the Active population (% of total population) in Macedonia in 2008 to that in 2010?
Provide a succinct answer. 1. What is the ratio of the Active population (% of total population) of Thailand in 2008 to that in 2010?
Provide a succinct answer. 1.02. What is the ratio of the Active population (% of total population) in Central Europe in 2008 to that in 2011?
Your response must be concise. 0.99. What is the ratio of the Active population (% of total population) of North America in 2008 to that in 2011?
Provide a succinct answer. 1.02. What is the ratio of the Active population (% of total population) in Macedonia in 2008 to that in 2011?
Ensure brevity in your answer.  0.98. What is the ratio of the Active population (% of total population) of Thailand in 2008 to that in 2011?
Provide a succinct answer. 1.02. What is the ratio of the Active population (% of total population) in North America in 2008 to that in 2012?
Ensure brevity in your answer.  1.03. What is the ratio of the Active population (% of total population) in Thailand in 2008 to that in 2012?
Your answer should be compact. 1.02. What is the ratio of the Active population (% of total population) in Central Europe in 2008 to that in 2013?
Give a very brief answer. 0.98. What is the ratio of the Active population (% of total population) in North America in 2008 to that in 2013?
Your answer should be very brief. 1.04. What is the ratio of the Active population (% of total population) of Macedonia in 2008 to that in 2013?
Provide a succinct answer. 0.96. What is the ratio of the Active population (% of total population) in Thailand in 2008 to that in 2013?
Your response must be concise. 1.04. What is the ratio of the Active population (% of total population) of Central Europe in 2008 to that in 2014?
Keep it short and to the point. 0.98. What is the ratio of the Active population (% of total population) in North America in 2008 to that in 2014?
Provide a succinct answer. 1.04. What is the ratio of the Active population (% of total population) of Macedonia in 2008 to that in 2014?
Offer a very short reply. 0.97. What is the ratio of the Active population (% of total population) in Thailand in 2008 to that in 2014?
Provide a short and direct response. 1.07. What is the ratio of the Active population (% of total population) of Central Europe in 2009 to that in 2010?
Give a very brief answer. 1. What is the ratio of the Active population (% of total population) in North America in 2009 to that in 2010?
Offer a very short reply. 1.01. What is the ratio of the Active population (% of total population) of North America in 2009 to that in 2011?
Your answer should be compact. 1.02. What is the ratio of the Active population (% of total population) of Macedonia in 2009 to that in 2011?
Your answer should be compact. 0.98. What is the ratio of the Active population (% of total population) of Thailand in 2009 to that in 2011?
Your answer should be very brief. 1.01. What is the ratio of the Active population (% of total population) in North America in 2009 to that in 2012?
Keep it short and to the point. 1.02. What is the ratio of the Active population (% of total population) of Thailand in 2009 to that in 2012?
Offer a very short reply. 1.01. What is the ratio of the Active population (% of total population) of Central Europe in 2009 to that in 2013?
Offer a terse response. 0.99. What is the ratio of the Active population (% of total population) in North America in 2009 to that in 2013?
Provide a succinct answer. 1.03. What is the ratio of the Active population (% of total population) of Macedonia in 2009 to that in 2013?
Your answer should be compact. 0.96. What is the ratio of the Active population (% of total population) in Thailand in 2009 to that in 2013?
Offer a terse response. 1.02. What is the ratio of the Active population (% of total population) of Central Europe in 2009 to that in 2014?
Make the answer very short. 0.98. What is the ratio of the Active population (% of total population) of North America in 2009 to that in 2014?
Give a very brief answer. 1.04. What is the ratio of the Active population (% of total population) of Macedonia in 2009 to that in 2014?
Provide a succinct answer. 0.97. What is the ratio of the Active population (% of total population) in Thailand in 2009 to that in 2014?
Provide a short and direct response. 1.05. What is the ratio of the Active population (% of total population) in North America in 2010 to that in 2011?
Provide a short and direct response. 1.01. What is the ratio of the Active population (% of total population) in Macedonia in 2010 to that in 2011?
Keep it short and to the point. 0.99. What is the ratio of the Active population (% of total population) in Central Europe in 2010 to that in 2012?
Your answer should be very brief. 0.99. What is the ratio of the Active population (% of total population) in North America in 2010 to that in 2012?
Offer a very short reply. 1.01. What is the ratio of the Active population (% of total population) in Macedonia in 2010 to that in 2012?
Keep it short and to the point. 1. What is the ratio of the Active population (% of total population) of Thailand in 2010 to that in 2012?
Offer a very short reply. 1. What is the ratio of the Active population (% of total population) of Central Europe in 2010 to that in 2013?
Offer a terse response. 0.99. What is the ratio of the Active population (% of total population) of North America in 2010 to that in 2013?
Provide a succinct answer. 1.02. What is the ratio of the Active population (% of total population) of Thailand in 2010 to that in 2013?
Make the answer very short. 1.02. What is the ratio of the Active population (% of total population) in Central Europe in 2010 to that in 2014?
Ensure brevity in your answer.  0.98. What is the ratio of the Active population (% of total population) of North America in 2010 to that in 2014?
Offer a very short reply. 1.03. What is the ratio of the Active population (% of total population) of Thailand in 2010 to that in 2014?
Keep it short and to the point. 1.04. What is the ratio of the Active population (% of total population) of Central Europe in 2011 to that in 2012?
Your response must be concise. 0.99. What is the ratio of the Active population (% of total population) of Macedonia in 2011 to that in 2012?
Offer a terse response. 1.01. What is the ratio of the Active population (% of total population) of Central Europe in 2011 to that in 2013?
Keep it short and to the point. 0.99. What is the ratio of the Active population (% of total population) of North America in 2011 to that in 2013?
Your response must be concise. 1.01. What is the ratio of the Active population (% of total population) in Macedonia in 2011 to that in 2013?
Offer a terse response. 0.98. What is the ratio of the Active population (% of total population) in Thailand in 2011 to that in 2013?
Ensure brevity in your answer.  1.02. What is the ratio of the Active population (% of total population) of Central Europe in 2011 to that in 2014?
Your answer should be very brief. 0.98. What is the ratio of the Active population (% of total population) in North America in 2011 to that in 2014?
Provide a succinct answer. 1.02. What is the ratio of the Active population (% of total population) in Macedonia in 2011 to that in 2014?
Offer a terse response. 0.99. What is the ratio of the Active population (% of total population) of Thailand in 2011 to that in 2014?
Your answer should be compact. 1.04. What is the ratio of the Active population (% of total population) of Central Europe in 2012 to that in 2013?
Ensure brevity in your answer.  1. What is the ratio of the Active population (% of total population) of North America in 2012 to that in 2013?
Provide a succinct answer. 1.01. What is the ratio of the Active population (% of total population) in Macedonia in 2012 to that in 2013?
Your response must be concise. 0.97. What is the ratio of the Active population (% of total population) in Thailand in 2012 to that in 2013?
Keep it short and to the point. 1.02. What is the ratio of the Active population (% of total population) in Central Europe in 2012 to that in 2014?
Your answer should be compact. 0.99. What is the ratio of the Active population (% of total population) in North America in 2012 to that in 2014?
Your answer should be compact. 1.01. What is the ratio of the Active population (% of total population) of Macedonia in 2012 to that in 2014?
Give a very brief answer. 0.98. What is the ratio of the Active population (% of total population) in Thailand in 2012 to that in 2014?
Provide a succinct answer. 1.04. What is the ratio of the Active population (% of total population) in Central Europe in 2013 to that in 2014?
Ensure brevity in your answer.  0.99. What is the ratio of the Active population (% of total population) in Macedonia in 2013 to that in 2014?
Your answer should be compact. 1.01. What is the ratio of the Active population (% of total population) in Thailand in 2013 to that in 2014?
Your answer should be very brief. 1.03. What is the difference between the highest and the second highest Active population (% of total population) of Central Europe?
Ensure brevity in your answer.  0.38. What is the difference between the highest and the second highest Active population (% of total population) of North America?
Your answer should be very brief. 0.19. What is the difference between the highest and the second highest Active population (% of total population) in Macedonia?
Provide a short and direct response. 0.5. What is the difference between the highest and the second highest Active population (% of total population) in Thailand?
Provide a succinct answer. 0.2. What is the difference between the highest and the lowest Active population (% of total population) in Central Europe?
Provide a short and direct response. 1.26. What is the difference between the highest and the lowest Active population (% of total population) in North America?
Make the answer very short. 2.34. What is the difference between the highest and the lowest Active population (% of total population) in Macedonia?
Your answer should be compact. 1.9. What is the difference between the highest and the lowest Active population (% of total population) of Thailand?
Give a very brief answer. 4.3. 